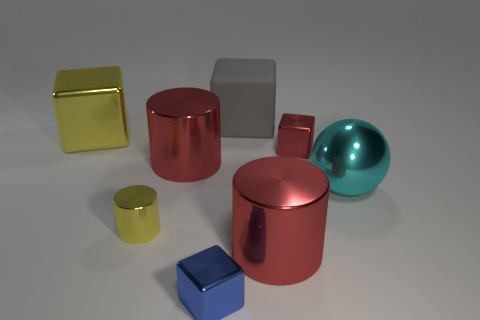Add 1 large matte things. How many objects exist? 9 Subtract all gray cubes. How many cubes are left? 3 Subtract all big red cylinders. How many cylinders are left? 1 Subtract 0 brown cylinders. How many objects are left? 8 Subtract all cylinders. How many objects are left? 5 Subtract 3 cylinders. How many cylinders are left? 0 Subtract all gray cylinders. Subtract all red cubes. How many cylinders are left? 3 Subtract all yellow cylinders. How many green balls are left? 0 Subtract all big gray matte blocks. Subtract all big yellow things. How many objects are left? 6 Add 6 large red metallic cylinders. How many large red metallic cylinders are left? 8 